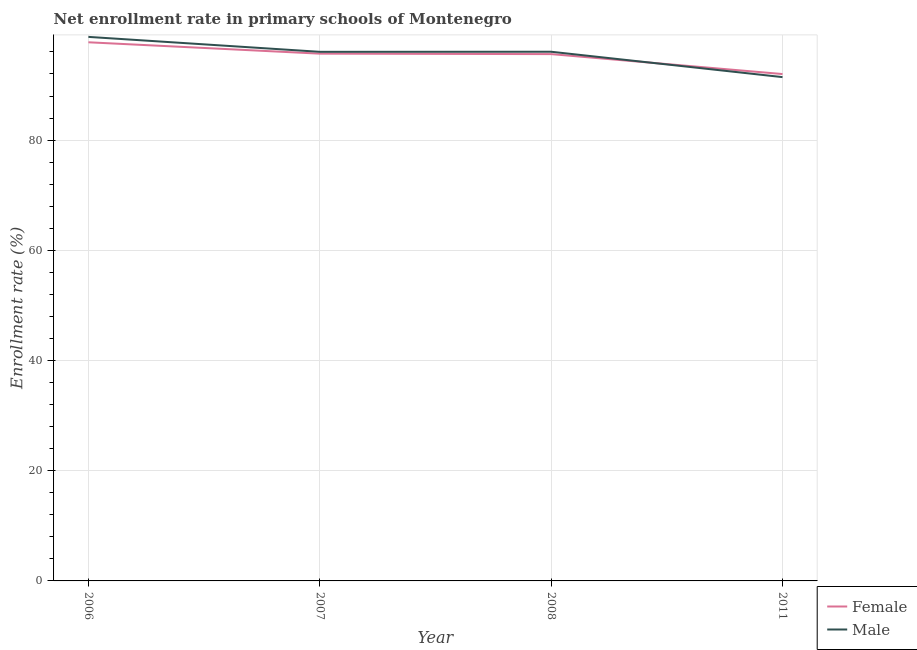How many different coloured lines are there?
Make the answer very short. 2. What is the enrollment rate of male students in 2007?
Your answer should be compact. 96.02. Across all years, what is the maximum enrollment rate of female students?
Keep it short and to the point. 97.76. Across all years, what is the minimum enrollment rate of female students?
Provide a succinct answer. 91.99. In which year was the enrollment rate of male students minimum?
Provide a succinct answer. 2011. What is the total enrollment rate of female students in the graph?
Your answer should be compact. 381.05. What is the difference between the enrollment rate of female students in 2006 and that in 2011?
Give a very brief answer. 5.77. What is the difference between the enrollment rate of male students in 2006 and the enrollment rate of female students in 2007?
Give a very brief answer. 3.04. What is the average enrollment rate of female students per year?
Your answer should be very brief. 95.26. In the year 2011, what is the difference between the enrollment rate of male students and enrollment rate of female students?
Your answer should be compact. -0.56. In how many years, is the enrollment rate of female students greater than 28 %?
Make the answer very short. 4. What is the ratio of the enrollment rate of female students in 2006 to that in 2011?
Keep it short and to the point. 1.06. What is the difference between the highest and the second highest enrollment rate of male students?
Offer a very short reply. 2.7. What is the difference between the highest and the lowest enrollment rate of female students?
Provide a short and direct response. 5.77. In how many years, is the enrollment rate of female students greater than the average enrollment rate of female students taken over all years?
Provide a succinct answer. 3. Does the enrollment rate of male students monotonically increase over the years?
Offer a terse response. No. Is the enrollment rate of male students strictly greater than the enrollment rate of female students over the years?
Make the answer very short. No. Is the enrollment rate of male students strictly less than the enrollment rate of female students over the years?
Provide a short and direct response. No. How many years are there in the graph?
Your answer should be very brief. 4. Are the values on the major ticks of Y-axis written in scientific E-notation?
Keep it short and to the point. No. What is the title of the graph?
Offer a very short reply. Net enrollment rate in primary schools of Montenegro. Does "Secondary education" appear as one of the legend labels in the graph?
Provide a short and direct response. No. What is the label or title of the X-axis?
Give a very brief answer. Year. What is the label or title of the Y-axis?
Your response must be concise. Enrollment rate (%). What is the Enrollment rate (%) of Female in 2006?
Your response must be concise. 97.76. What is the Enrollment rate (%) of Male in 2006?
Provide a succinct answer. 98.73. What is the Enrollment rate (%) of Female in 2007?
Offer a very short reply. 95.69. What is the Enrollment rate (%) in Male in 2007?
Provide a succinct answer. 96.02. What is the Enrollment rate (%) in Female in 2008?
Your answer should be compact. 95.61. What is the Enrollment rate (%) of Male in 2008?
Provide a short and direct response. 96.04. What is the Enrollment rate (%) of Female in 2011?
Your answer should be very brief. 91.99. What is the Enrollment rate (%) of Male in 2011?
Ensure brevity in your answer.  91.44. Across all years, what is the maximum Enrollment rate (%) in Female?
Give a very brief answer. 97.76. Across all years, what is the maximum Enrollment rate (%) of Male?
Your response must be concise. 98.73. Across all years, what is the minimum Enrollment rate (%) of Female?
Your answer should be compact. 91.99. Across all years, what is the minimum Enrollment rate (%) of Male?
Your answer should be compact. 91.44. What is the total Enrollment rate (%) of Female in the graph?
Your answer should be compact. 381.05. What is the total Enrollment rate (%) in Male in the graph?
Provide a succinct answer. 382.23. What is the difference between the Enrollment rate (%) in Female in 2006 and that in 2007?
Your answer should be compact. 2.06. What is the difference between the Enrollment rate (%) in Male in 2006 and that in 2007?
Provide a short and direct response. 2.71. What is the difference between the Enrollment rate (%) of Female in 2006 and that in 2008?
Your response must be concise. 2.15. What is the difference between the Enrollment rate (%) in Male in 2006 and that in 2008?
Your response must be concise. 2.7. What is the difference between the Enrollment rate (%) of Female in 2006 and that in 2011?
Keep it short and to the point. 5.77. What is the difference between the Enrollment rate (%) of Male in 2006 and that in 2011?
Offer a terse response. 7.3. What is the difference between the Enrollment rate (%) of Female in 2007 and that in 2008?
Ensure brevity in your answer.  0.08. What is the difference between the Enrollment rate (%) in Male in 2007 and that in 2008?
Your answer should be very brief. -0.02. What is the difference between the Enrollment rate (%) in Female in 2007 and that in 2011?
Give a very brief answer. 3.7. What is the difference between the Enrollment rate (%) of Male in 2007 and that in 2011?
Keep it short and to the point. 4.59. What is the difference between the Enrollment rate (%) in Female in 2008 and that in 2011?
Make the answer very short. 3.62. What is the difference between the Enrollment rate (%) in Male in 2008 and that in 2011?
Your answer should be very brief. 4.6. What is the difference between the Enrollment rate (%) in Female in 2006 and the Enrollment rate (%) in Male in 2007?
Offer a very short reply. 1.73. What is the difference between the Enrollment rate (%) of Female in 2006 and the Enrollment rate (%) of Male in 2008?
Your response must be concise. 1.72. What is the difference between the Enrollment rate (%) of Female in 2006 and the Enrollment rate (%) of Male in 2011?
Keep it short and to the point. 6.32. What is the difference between the Enrollment rate (%) of Female in 2007 and the Enrollment rate (%) of Male in 2008?
Offer a very short reply. -0.35. What is the difference between the Enrollment rate (%) of Female in 2007 and the Enrollment rate (%) of Male in 2011?
Provide a succinct answer. 4.26. What is the difference between the Enrollment rate (%) of Female in 2008 and the Enrollment rate (%) of Male in 2011?
Provide a succinct answer. 4.17. What is the average Enrollment rate (%) of Female per year?
Make the answer very short. 95.26. What is the average Enrollment rate (%) of Male per year?
Provide a succinct answer. 95.56. In the year 2006, what is the difference between the Enrollment rate (%) in Female and Enrollment rate (%) in Male?
Make the answer very short. -0.98. In the year 2007, what is the difference between the Enrollment rate (%) in Female and Enrollment rate (%) in Male?
Your answer should be very brief. -0.33. In the year 2008, what is the difference between the Enrollment rate (%) of Female and Enrollment rate (%) of Male?
Ensure brevity in your answer.  -0.43. In the year 2011, what is the difference between the Enrollment rate (%) in Female and Enrollment rate (%) in Male?
Give a very brief answer. 0.56. What is the ratio of the Enrollment rate (%) in Female in 2006 to that in 2007?
Your answer should be compact. 1.02. What is the ratio of the Enrollment rate (%) of Male in 2006 to that in 2007?
Provide a succinct answer. 1.03. What is the ratio of the Enrollment rate (%) in Female in 2006 to that in 2008?
Give a very brief answer. 1.02. What is the ratio of the Enrollment rate (%) in Male in 2006 to that in 2008?
Offer a very short reply. 1.03. What is the ratio of the Enrollment rate (%) of Female in 2006 to that in 2011?
Offer a very short reply. 1.06. What is the ratio of the Enrollment rate (%) in Male in 2006 to that in 2011?
Your response must be concise. 1.08. What is the ratio of the Enrollment rate (%) in Female in 2007 to that in 2011?
Provide a short and direct response. 1.04. What is the ratio of the Enrollment rate (%) in Male in 2007 to that in 2011?
Make the answer very short. 1.05. What is the ratio of the Enrollment rate (%) in Female in 2008 to that in 2011?
Keep it short and to the point. 1.04. What is the ratio of the Enrollment rate (%) in Male in 2008 to that in 2011?
Your answer should be compact. 1.05. What is the difference between the highest and the second highest Enrollment rate (%) of Female?
Give a very brief answer. 2.06. What is the difference between the highest and the second highest Enrollment rate (%) of Male?
Make the answer very short. 2.7. What is the difference between the highest and the lowest Enrollment rate (%) in Female?
Your answer should be very brief. 5.77. What is the difference between the highest and the lowest Enrollment rate (%) of Male?
Your answer should be very brief. 7.3. 